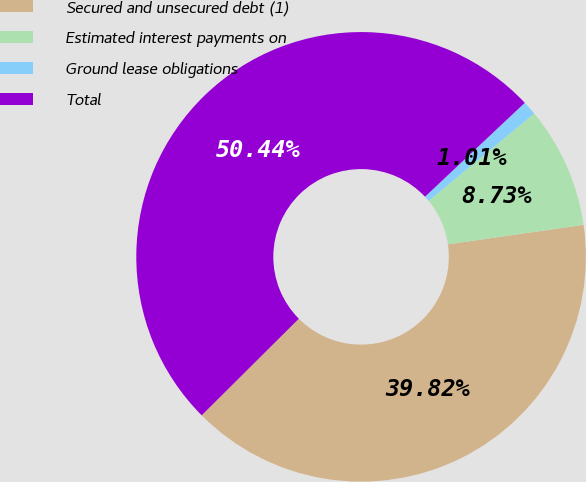<chart> <loc_0><loc_0><loc_500><loc_500><pie_chart><fcel>Secured and unsecured debt (1)<fcel>Estimated interest payments on<fcel>Ground lease obligations<fcel>Total<nl><fcel>39.82%<fcel>8.73%<fcel>1.01%<fcel>50.44%<nl></chart> 